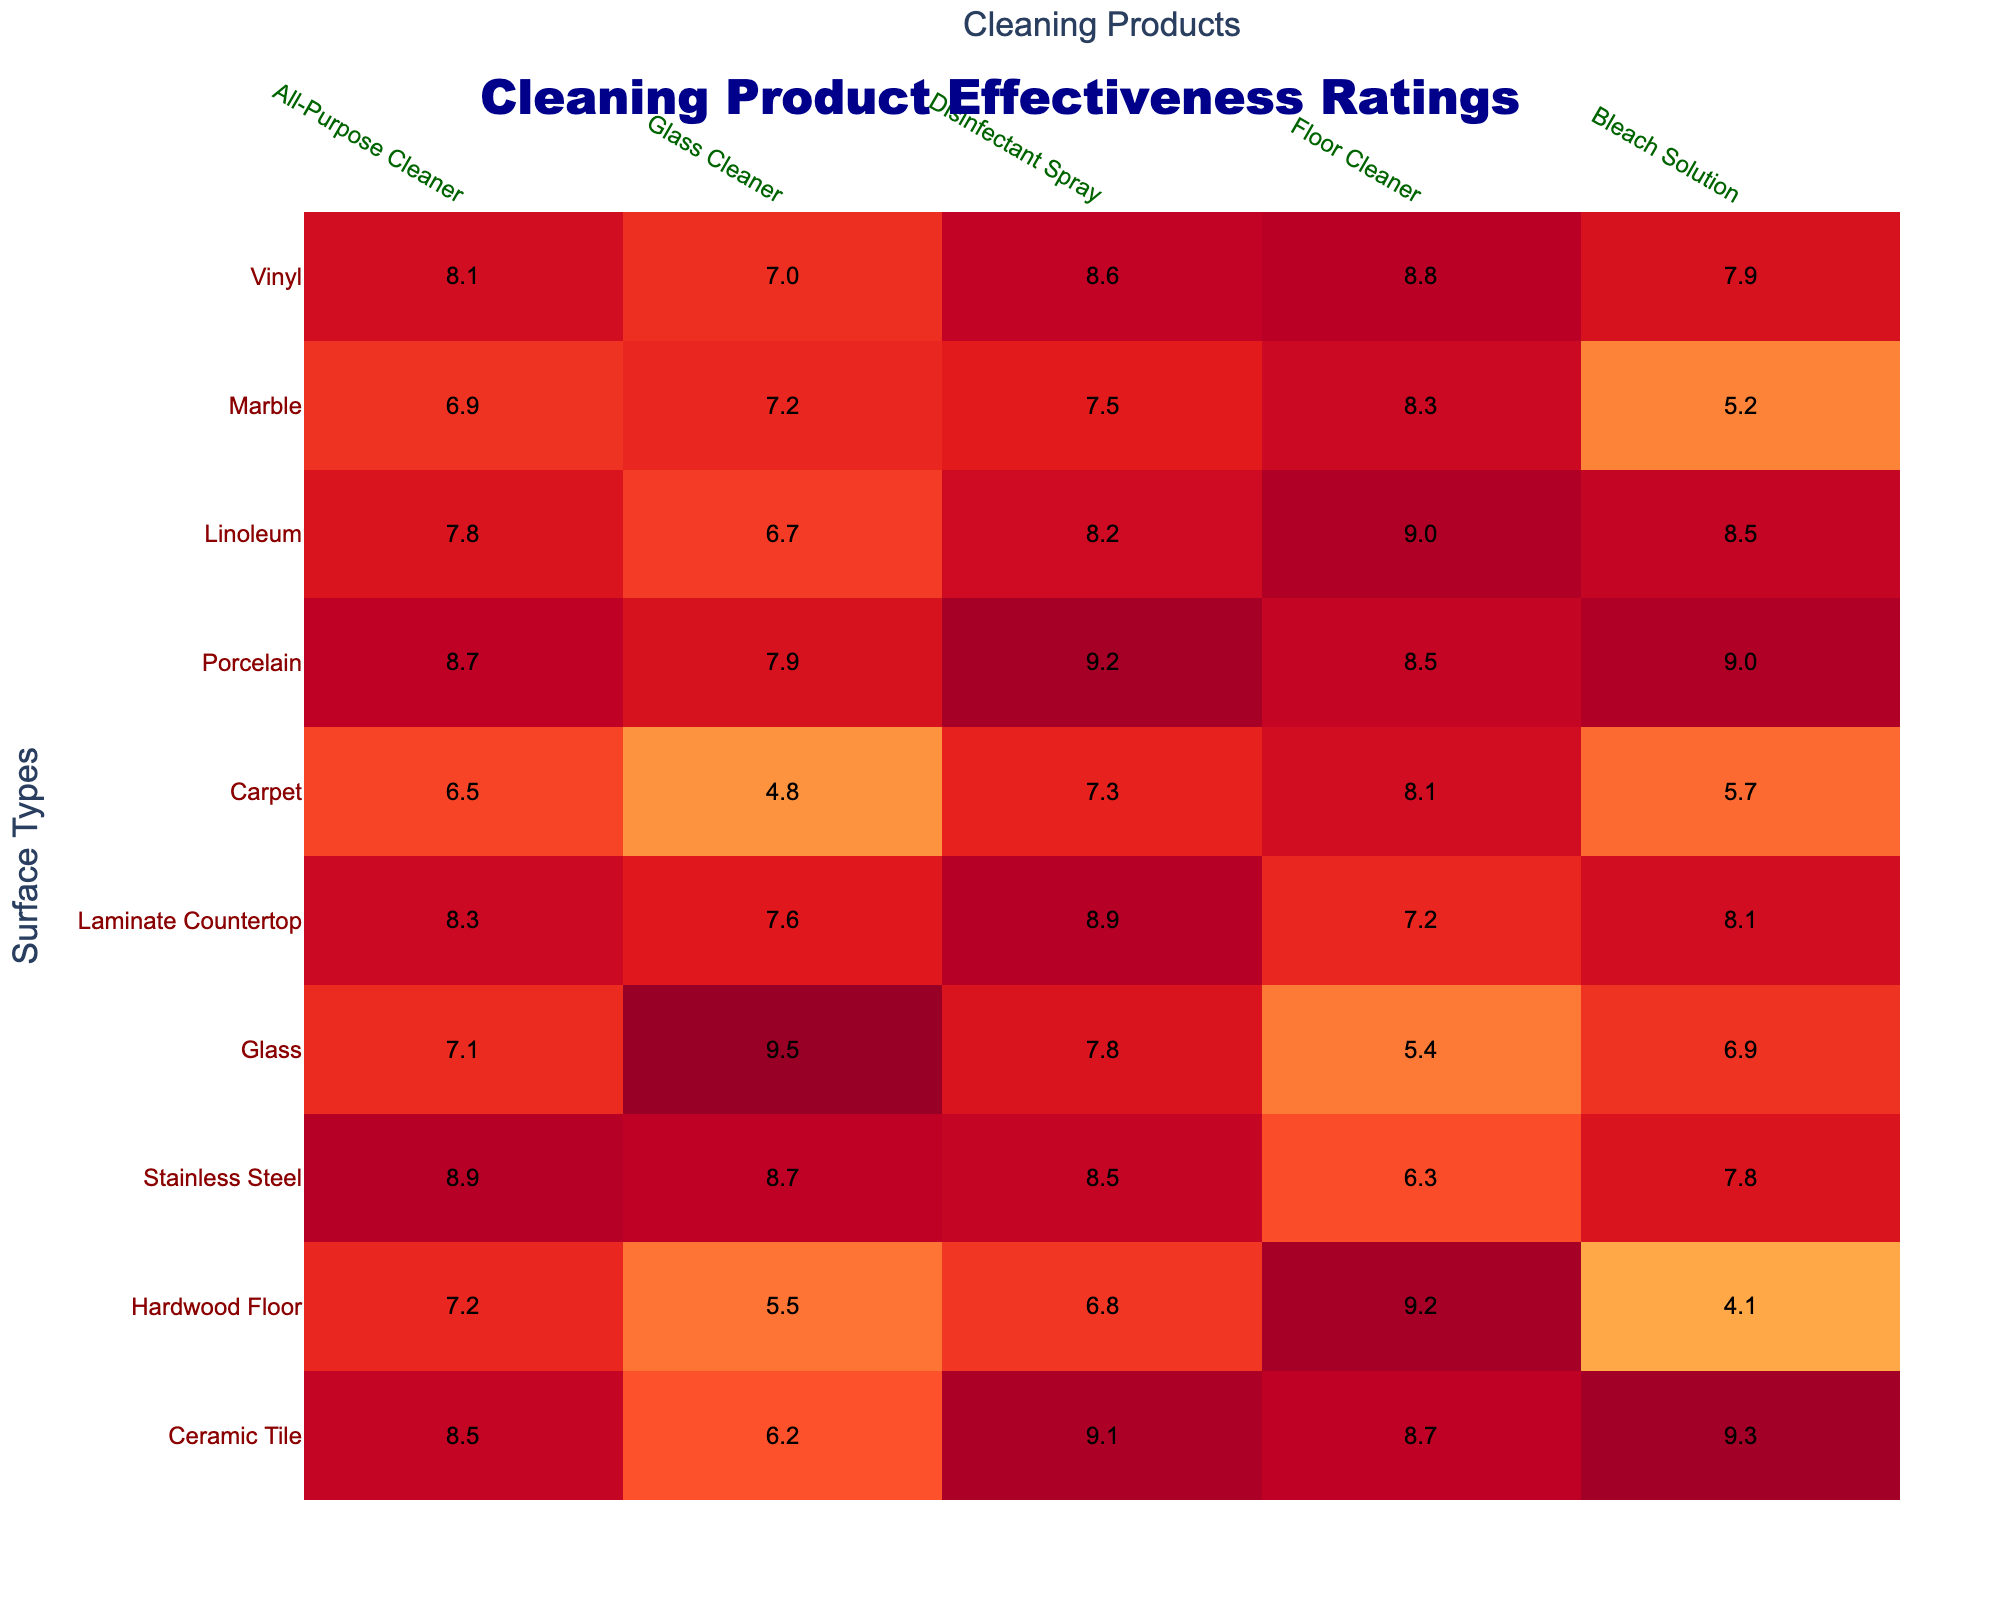What is the effectiveness rating of the All-Purpose Cleaner on Ceramic Tile? According to the table, the All-Purpose Cleaner has an effectiveness rating of 8.5 on Ceramic Tile.
Answer: 8.5 Which cleaning product has the highest rating for Glass surfaces? Looking at the Glass row, the highest rating is 9.5 for the Glass Cleaner.
Answer: 9.5 What is the average effectiveness rating of the Disinfectant Spray across all surfaces? To find the average, add the ratings for all surfaces: (9.1 + 6.8 + 8.5 + 7.8 + 8.9 + 7.3 + 9.2 + 8.2 + 7.5 + 8.6) = 78.5. There are 10 ratings, so the average is 78.5 / 10 = 7.85.
Answer: 7.85 Is the effectiveness rating of Bleach Solution higher on Porcelain than on Stainless Steel? The Bleach Solution rating for Porcelain is 9.0, while for Stainless Steel it is 7.8. Since 9.0 is greater than 7.8, the statement is true.
Answer: Yes Which surface type has the lowest rating for Carpet cleaning, and what is the rating? Reviewing the Carpet row, the lowest rating is 4.8 for the Glass Cleaner.
Answer: 4.8 for Glass Cleaner What cleaning product is the most effective on Hardwood Floors, and what is its rating? The highest rating for Hardwood Floor is 9.2, which comes from the Floor Cleaner.
Answer: 9.2 (Floor Cleaner) What is the difference in effectiveness ratings between the Disinfectant Spray on Ceramic Tile and on Hardwood Floor? The rating for Ceramic Tile with the Disinfectant Spray is 9.1, and for Hardwood Floor it is 6.8. The difference is 9.1 - 6.8 = 2.3.
Answer: 2.3 Which surface type has the highest rating for the All-Purpose Cleaner? The row for the All-Purpose Cleaner shows the highest rating of 8.9 for Stainless Steel.
Answer: Stainless Steel If you were to rank the effectiveness of the Floor Cleaner on all surfaces, which surface would rank the lowest and what is its rating? The Floor Cleaner ratings for every surface show that its lowest is for Glass at 5.4. So, it ranks the lowest on Glass.
Answer: Glass (5.4) Does the Bleach Solution perform better on Ceramic Tile compared to Laminate Countertop? Looking at the ratings, the Bleach Solution is rated 9.3 on Ceramic Tile and 8.1 on Laminate Countertop. Since 9.3 is greater than 8.1, it performs better on Ceramic Tile.
Answer: Yes 